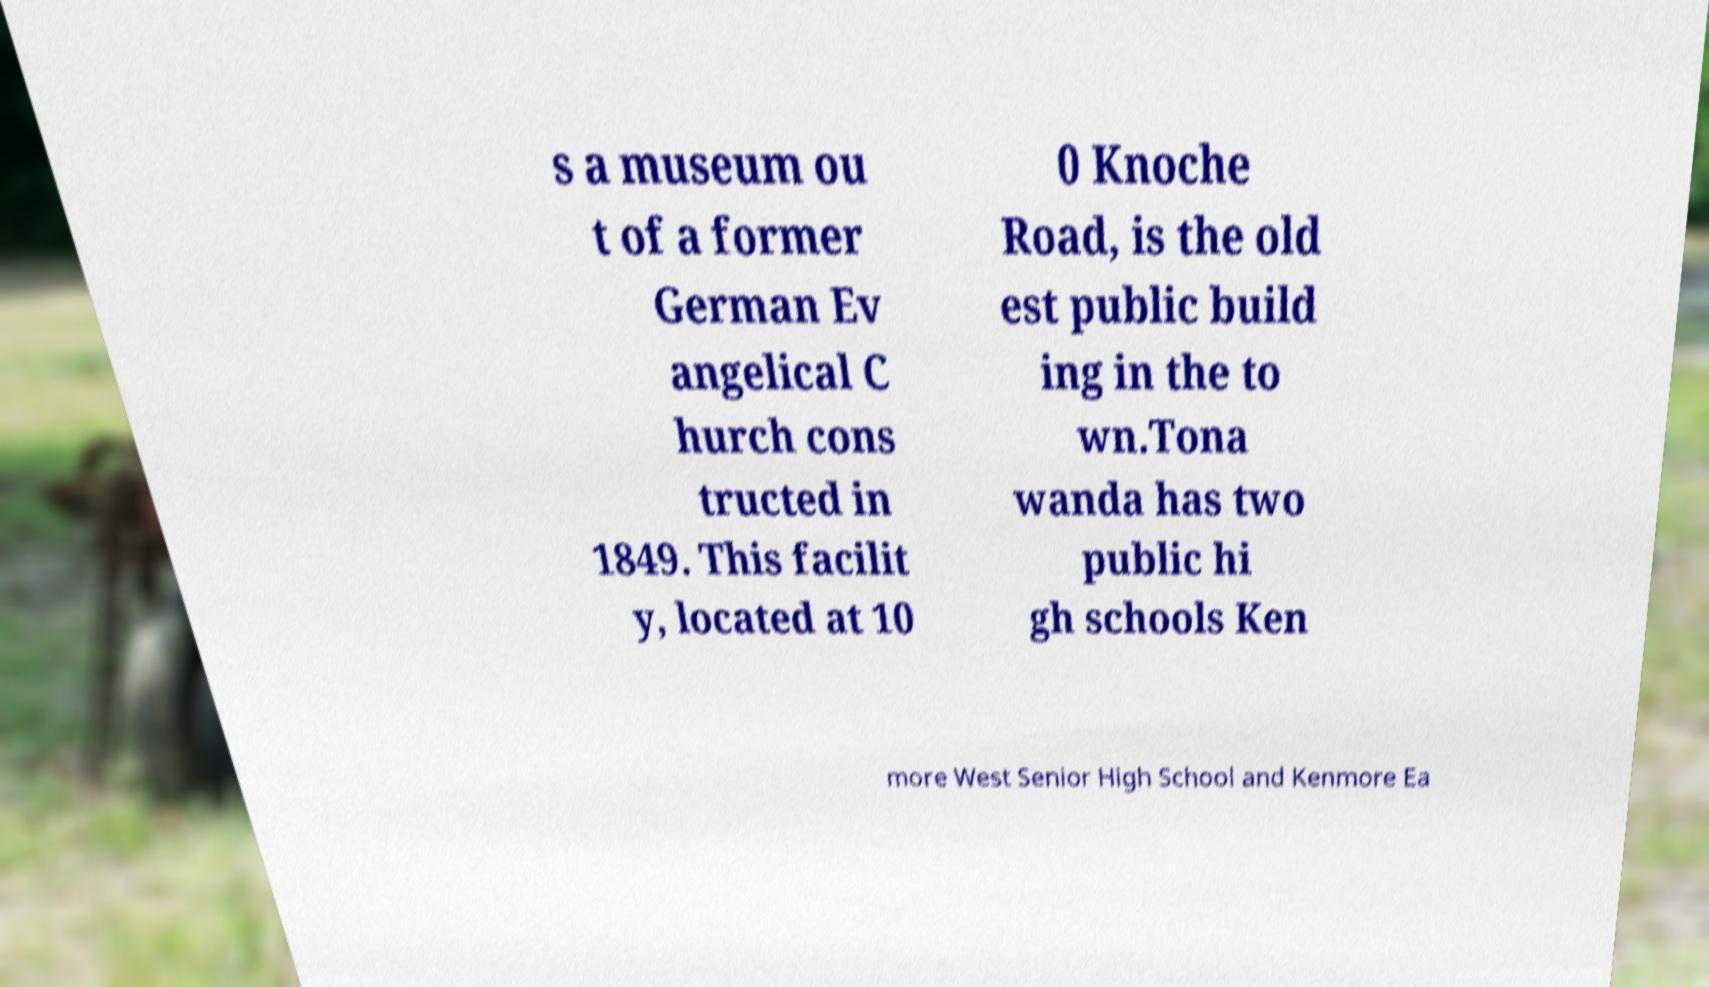Can you read and provide the text displayed in the image?This photo seems to have some interesting text. Can you extract and type it out for me? s a museum ou t of a former German Ev angelical C hurch cons tructed in 1849. This facilit y, located at 10 0 Knoche Road, is the old est public build ing in the to wn.Tona wanda has two public hi gh schools Ken more West Senior High School and Kenmore Ea 